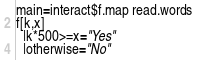<code> <loc_0><loc_0><loc_500><loc_500><_Haskell_>main=interact$f.map read.words
f[k,x]
  |k*500>=x="Yes"
  |otherwise="No"</code> 